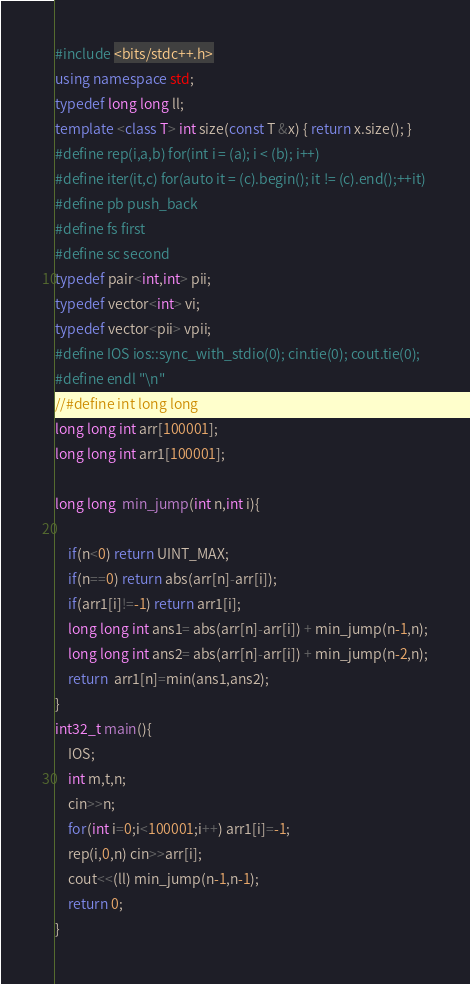<code> <loc_0><loc_0><loc_500><loc_500><_C++_>#include <bits/stdc++.h>
using namespace std;
typedef long long ll;
template <class T> int size(const T &x) { return x.size(); }
#define rep(i,a,b) for(int i = (a); i < (b); i++)
#define iter(it,c) for(auto it = (c).begin(); it != (c).end();++it)
#define pb push_back
#define fs first
#define sc second
typedef pair<int,int> pii;
typedef vector<int> vi;
typedef vector<pii> vpii;
#define IOS ios::sync_with_stdio(0); cin.tie(0); cout.tie(0);
#define endl "\n"
//#define int long long
long long int arr[100001];
long long int arr1[100001];
 
long long  min_jump(int n,int i){
    
    if(n<0) return UINT_MAX;
    if(n==0) return abs(arr[n]-arr[i]);
    if(arr1[i]!=-1) return arr1[i];
    long long int ans1= abs(arr[n]-arr[i]) + min_jump(n-1,n);
    long long int ans2= abs(arr[n]-arr[i]) + min_jump(n-2,n);
    return  arr1[n]=min(ans1,ans2);
}
int32_t main(){
    IOS;
    int m,t,n;
    cin>>n;
    for(int i=0;i<100001;i++) arr1[i]=-1;    
    rep(i,0,n) cin>>arr[i];
    cout<<(ll) min_jump(n-1,n-1);
    return 0;
}</code> 